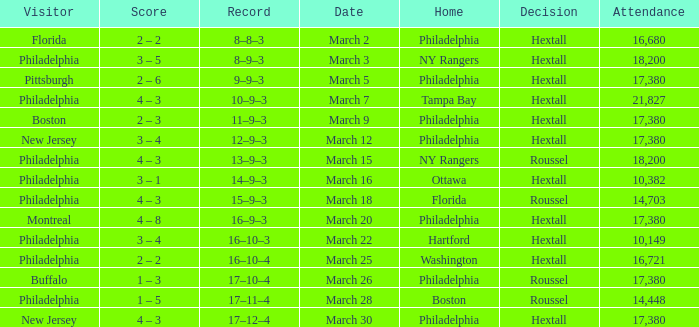Date of march 30 involves what home? Philadelphia. 